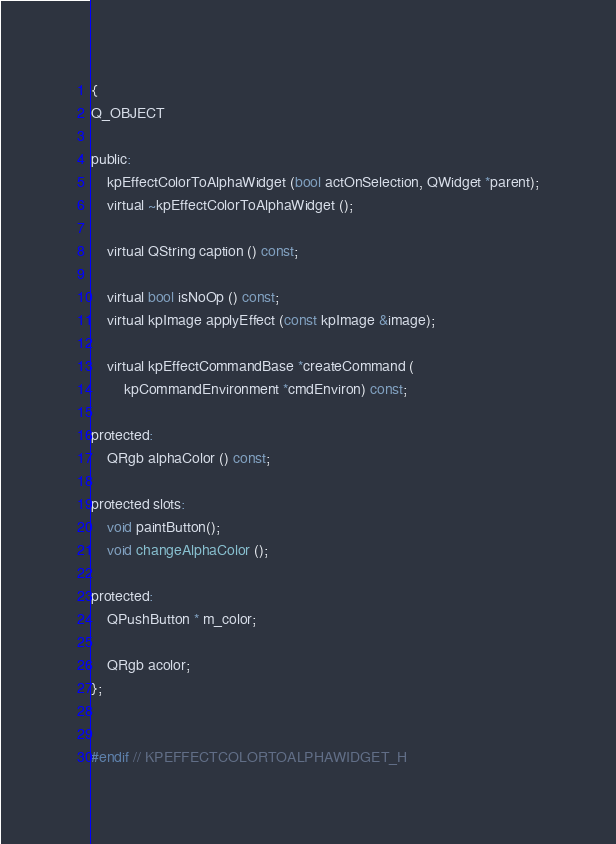<code> <loc_0><loc_0><loc_500><loc_500><_C_>{
Q_OBJECT

public:
    kpEffectColorToAlphaWidget (bool actOnSelection, QWidget *parent);
    virtual ~kpEffectColorToAlphaWidget ();

    virtual QString caption () const;

    virtual bool isNoOp () const;
    virtual kpImage applyEffect (const kpImage &image);

    virtual kpEffectCommandBase *createCommand (
        kpCommandEnvironment *cmdEnviron) const;

protected:
    QRgb alphaColor () const;

protected slots:
    void paintButton();
    void changeAlphaColor ();

protected:
    QPushButton * m_color;

    QRgb acolor;
};


#endif // KPEFFECTCOLORTOALPHAWIDGET_H
</code> 